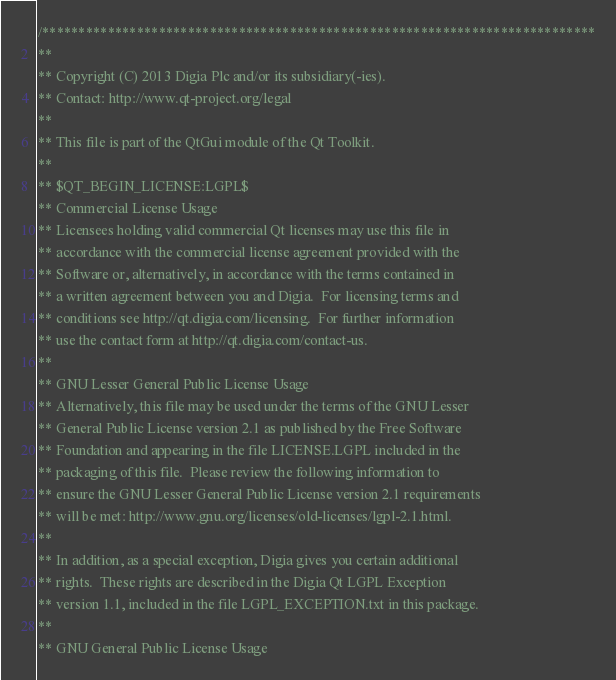Convert code to text. <code><loc_0><loc_0><loc_500><loc_500><_C++_>/****************************************************************************
**
** Copyright (C) 2013 Digia Plc and/or its subsidiary(-ies).
** Contact: http://www.qt-project.org/legal
**
** This file is part of the QtGui module of the Qt Toolkit.
**
** $QT_BEGIN_LICENSE:LGPL$
** Commercial License Usage
** Licensees holding valid commercial Qt licenses may use this file in
** accordance with the commercial license agreement provided with the
** Software or, alternatively, in accordance with the terms contained in
** a written agreement between you and Digia.  For licensing terms and
** conditions see http://qt.digia.com/licensing.  For further information
** use the contact form at http://qt.digia.com/contact-us.
**
** GNU Lesser General Public License Usage
** Alternatively, this file may be used under the terms of the GNU Lesser
** General Public License version 2.1 as published by the Free Software
** Foundation and appearing in the file LICENSE.LGPL included in the
** packaging of this file.  Please review the following information to
** ensure the GNU Lesser General Public License version 2.1 requirements
** will be met: http://www.gnu.org/licenses/old-licenses/lgpl-2.1.html.
**
** In addition, as a special exception, Digia gives you certain additional
** rights.  These rights are described in the Digia Qt LGPL Exception
** version 1.1, included in the file LGPL_EXCEPTION.txt in this package.
**
** GNU General Public License Usage</code> 